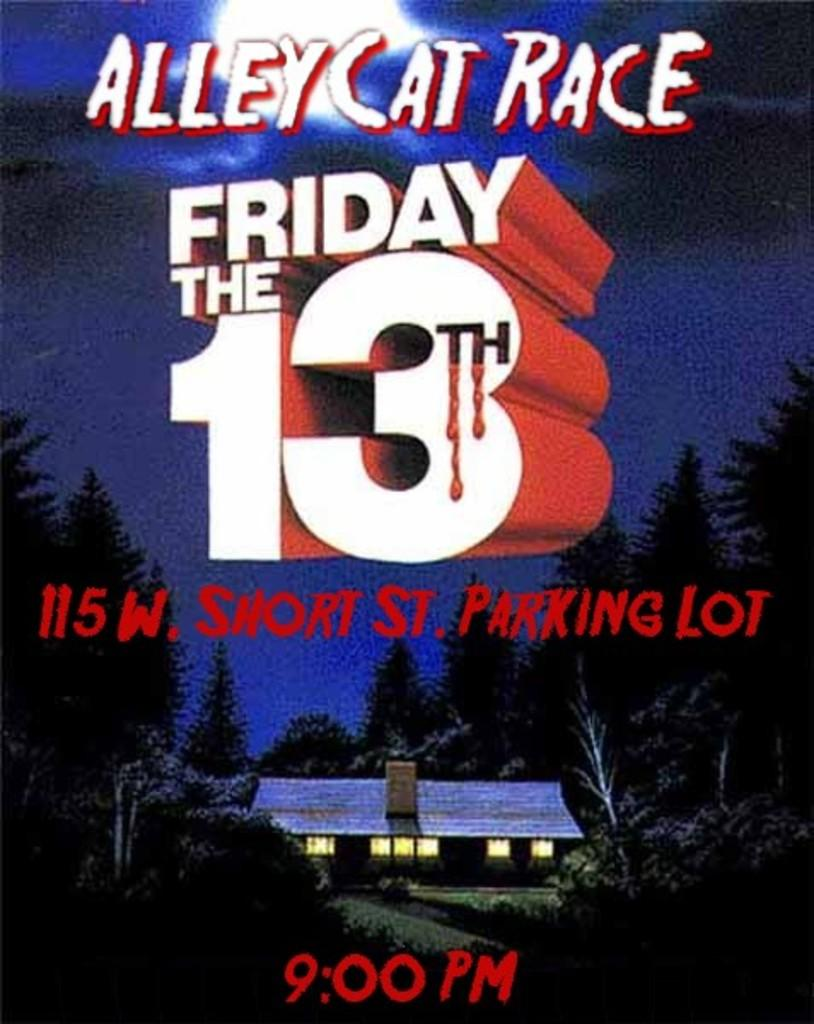Provide a one-sentence caption for the provided image. A poster advertising Friday the 13th Alley Cat Race. 